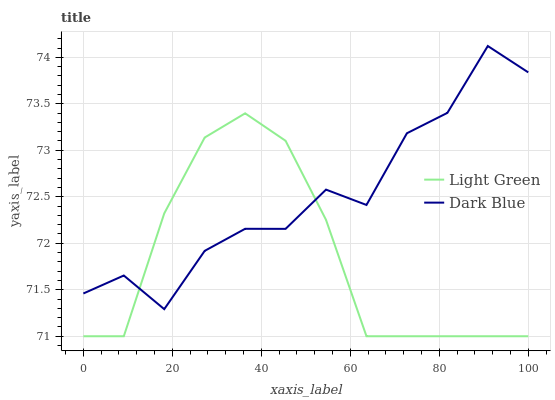Does Light Green have the minimum area under the curve?
Answer yes or no. Yes. Does Dark Blue have the maximum area under the curve?
Answer yes or no. Yes. Does Light Green have the maximum area under the curve?
Answer yes or no. No. Is Light Green the smoothest?
Answer yes or no. Yes. Is Dark Blue the roughest?
Answer yes or no. Yes. Is Light Green the roughest?
Answer yes or no. No. Does Light Green have the lowest value?
Answer yes or no. Yes. Does Dark Blue have the highest value?
Answer yes or no. Yes. Does Light Green have the highest value?
Answer yes or no. No. Does Dark Blue intersect Light Green?
Answer yes or no. Yes. Is Dark Blue less than Light Green?
Answer yes or no. No. Is Dark Blue greater than Light Green?
Answer yes or no. No. 